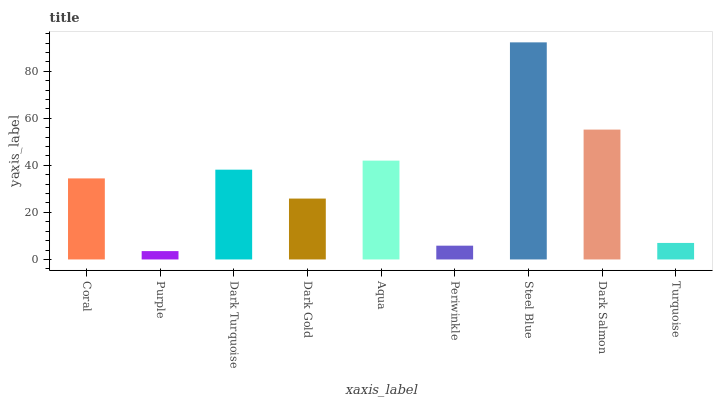Is Dark Turquoise the minimum?
Answer yes or no. No. Is Dark Turquoise the maximum?
Answer yes or no. No. Is Dark Turquoise greater than Purple?
Answer yes or no. Yes. Is Purple less than Dark Turquoise?
Answer yes or no. Yes. Is Purple greater than Dark Turquoise?
Answer yes or no. No. Is Dark Turquoise less than Purple?
Answer yes or no. No. Is Coral the high median?
Answer yes or no. Yes. Is Coral the low median?
Answer yes or no. Yes. Is Steel Blue the high median?
Answer yes or no. No. Is Aqua the low median?
Answer yes or no. No. 